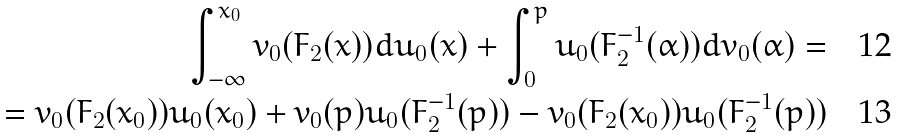Convert formula to latex. <formula><loc_0><loc_0><loc_500><loc_500>\int _ { - \infty } ^ { x _ { 0 } } v _ { 0 } ( F _ { 2 } ( x ) ) d u _ { 0 } ( x ) + \int _ { 0 } ^ { p } u _ { 0 } ( F _ { 2 } ^ { - 1 } ( \alpha ) ) d v _ { 0 } ( \alpha ) = \\ = v _ { 0 } ( F _ { 2 } ( x _ { 0 } ) ) u _ { 0 } ( x _ { 0 } ) + v _ { 0 } ( p ) u _ { 0 } ( F _ { 2 } ^ { - 1 } ( p ) ) - v _ { 0 } ( F _ { 2 } ( x _ { 0 } ) ) u _ { 0 } ( F _ { 2 } ^ { - 1 } ( p ) )</formula> 